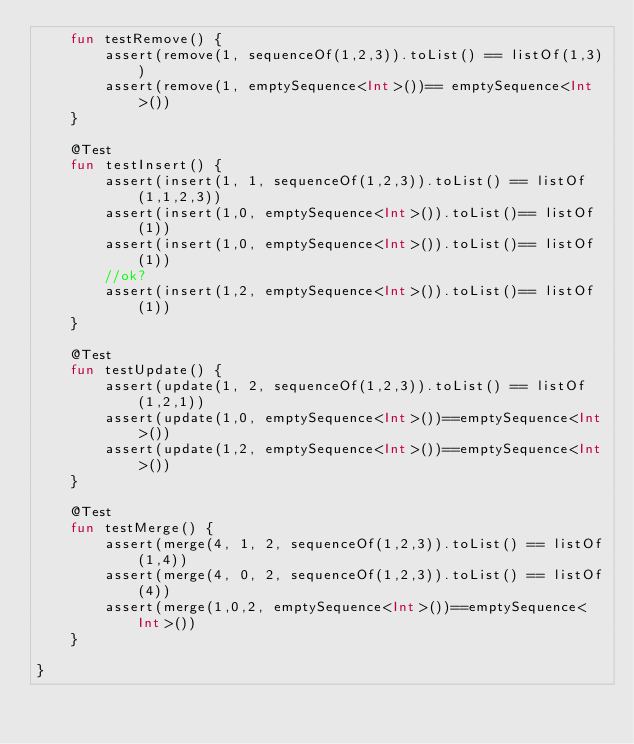Convert code to text. <code><loc_0><loc_0><loc_500><loc_500><_Kotlin_>    fun testRemove() {
        assert(remove(1, sequenceOf(1,2,3)).toList() == listOf(1,3))
        assert(remove(1, emptySequence<Int>())== emptySequence<Int>())
    }

    @Test
    fun testInsert() {
        assert(insert(1, 1, sequenceOf(1,2,3)).toList() == listOf(1,1,2,3))
        assert(insert(1,0, emptySequence<Int>()).toList()== listOf(1))
        assert(insert(1,0, emptySequence<Int>()).toList()== listOf(1))
        //ok?
        assert(insert(1,2, emptySequence<Int>()).toList()== listOf(1))
    }

    @Test
    fun testUpdate() {
        assert(update(1, 2, sequenceOf(1,2,3)).toList() == listOf(1,2,1))
        assert(update(1,0, emptySequence<Int>())==emptySequence<Int>())
        assert(update(1,2, emptySequence<Int>())==emptySequence<Int>())
    }

    @Test
    fun testMerge() {
        assert(merge(4, 1, 2, sequenceOf(1,2,3)).toList() == listOf(1,4))
        assert(merge(4, 0, 2, sequenceOf(1,2,3)).toList() == listOf(4))
        assert(merge(1,0,2, emptySequence<Int>())==emptySequence<Int>())
    }

}</code> 